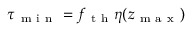Convert formula to latex. <formula><loc_0><loc_0><loc_500><loc_500>\tau _ { m i n } = f _ { t h } \eta ( z _ { m a x } )</formula> 